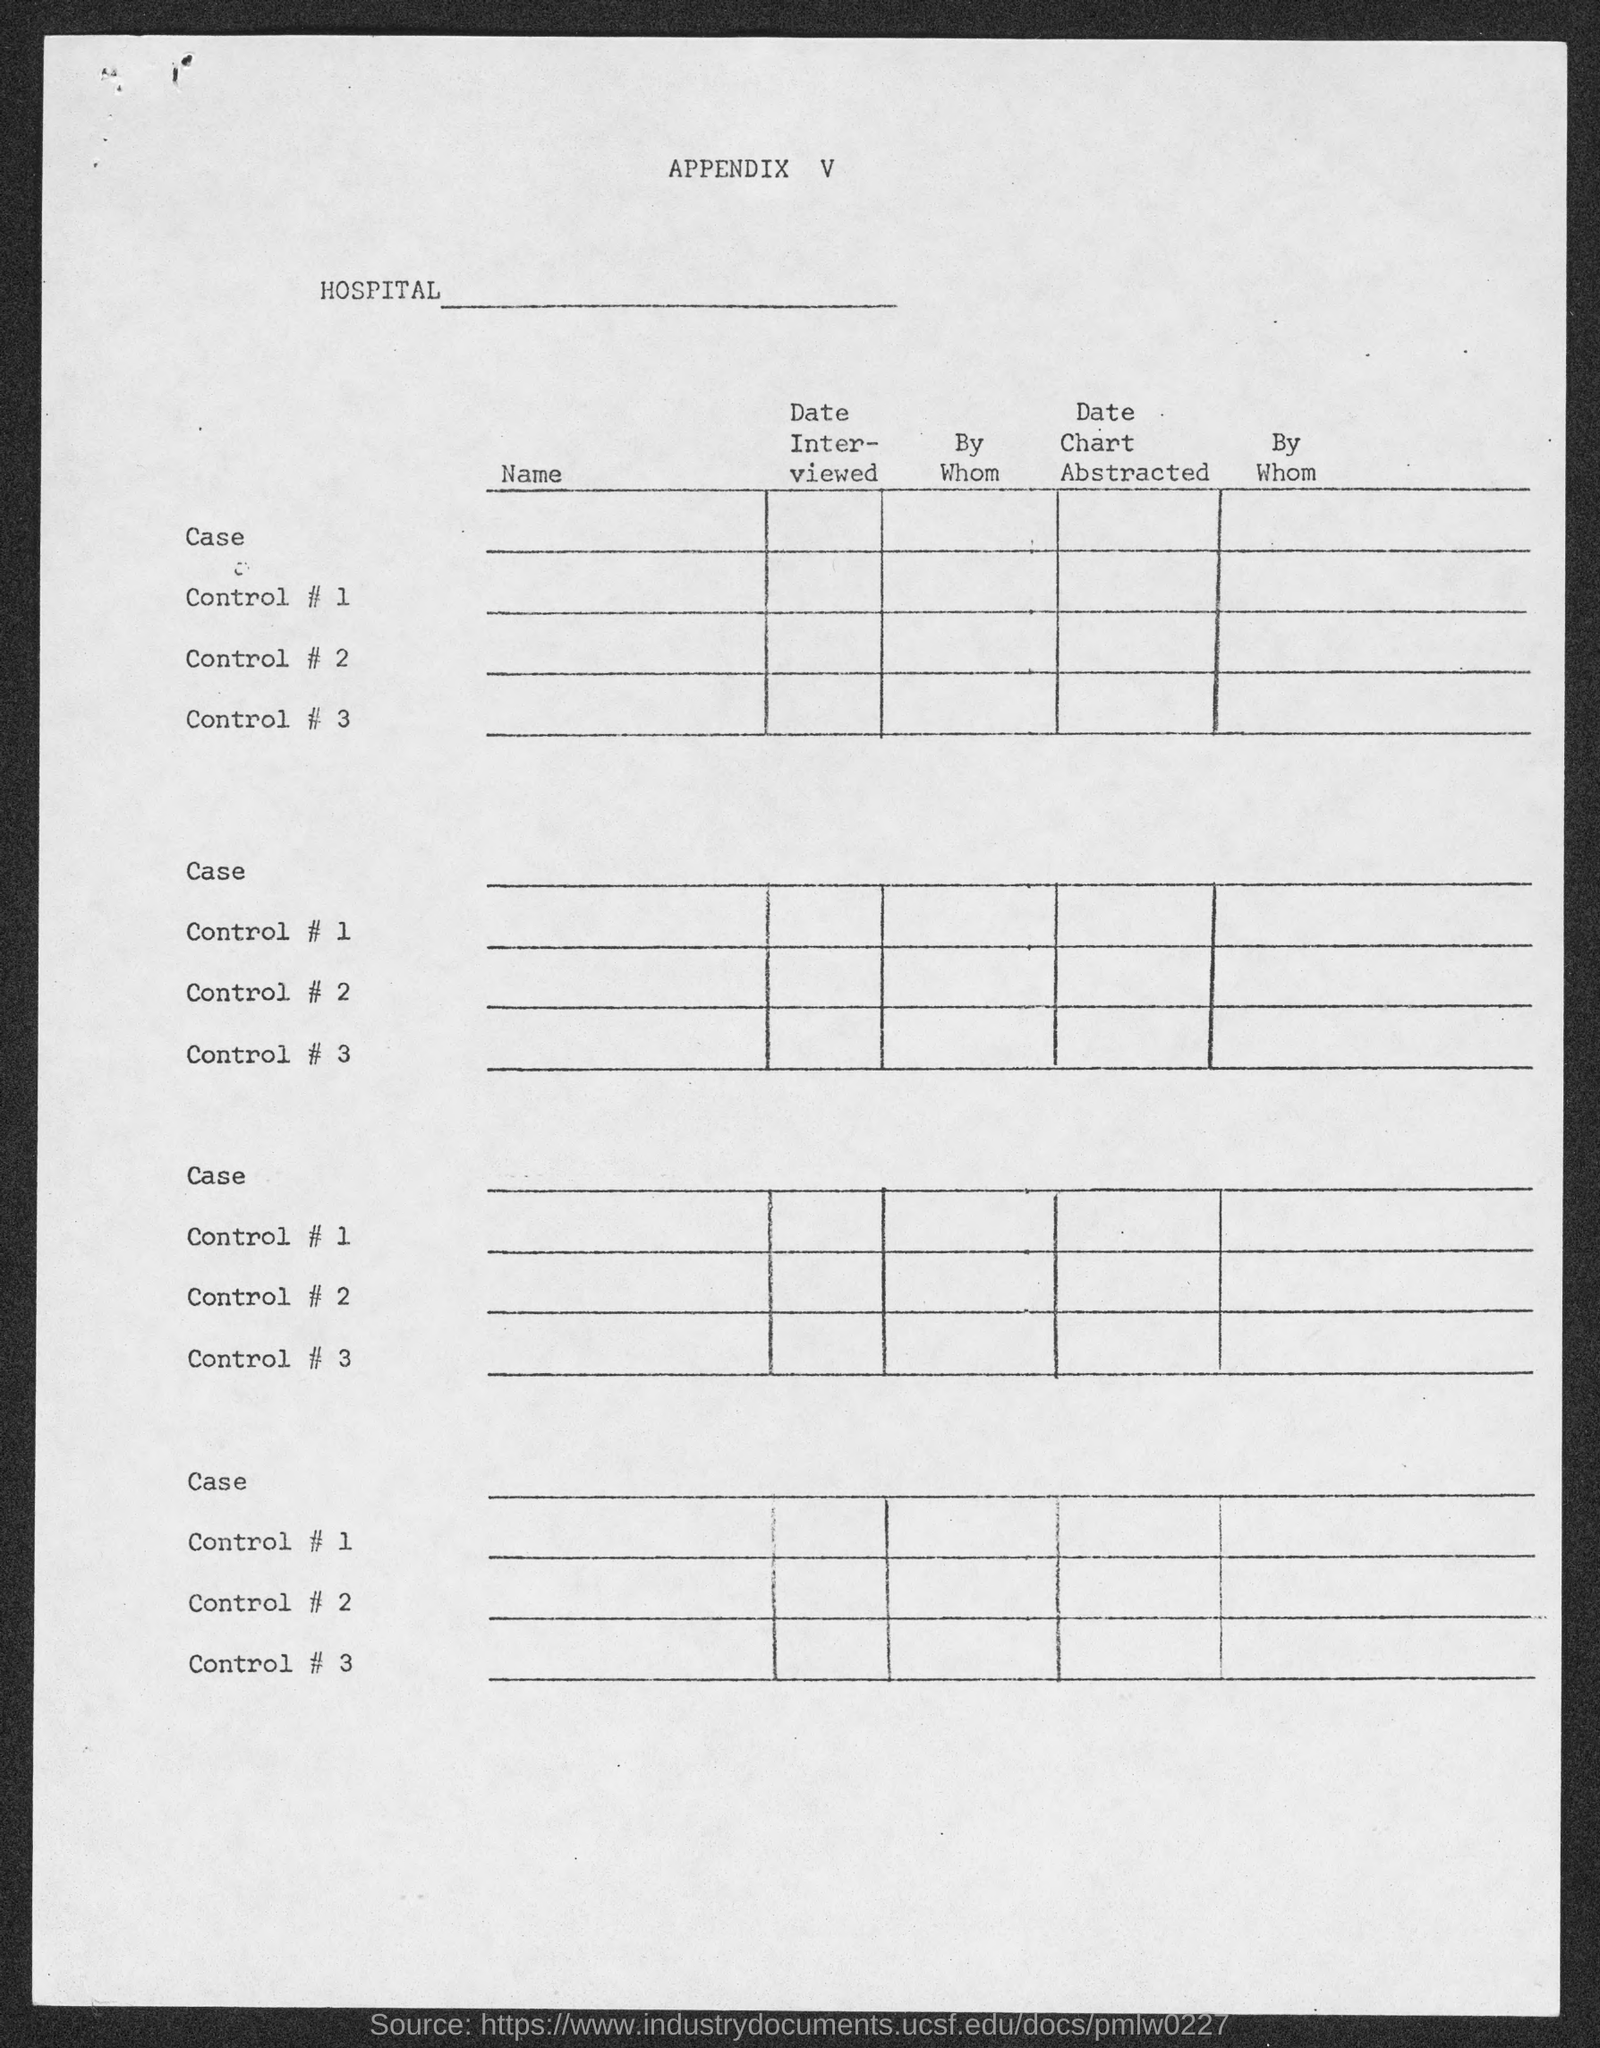Point out several critical features in this image. The appendix number is V... 